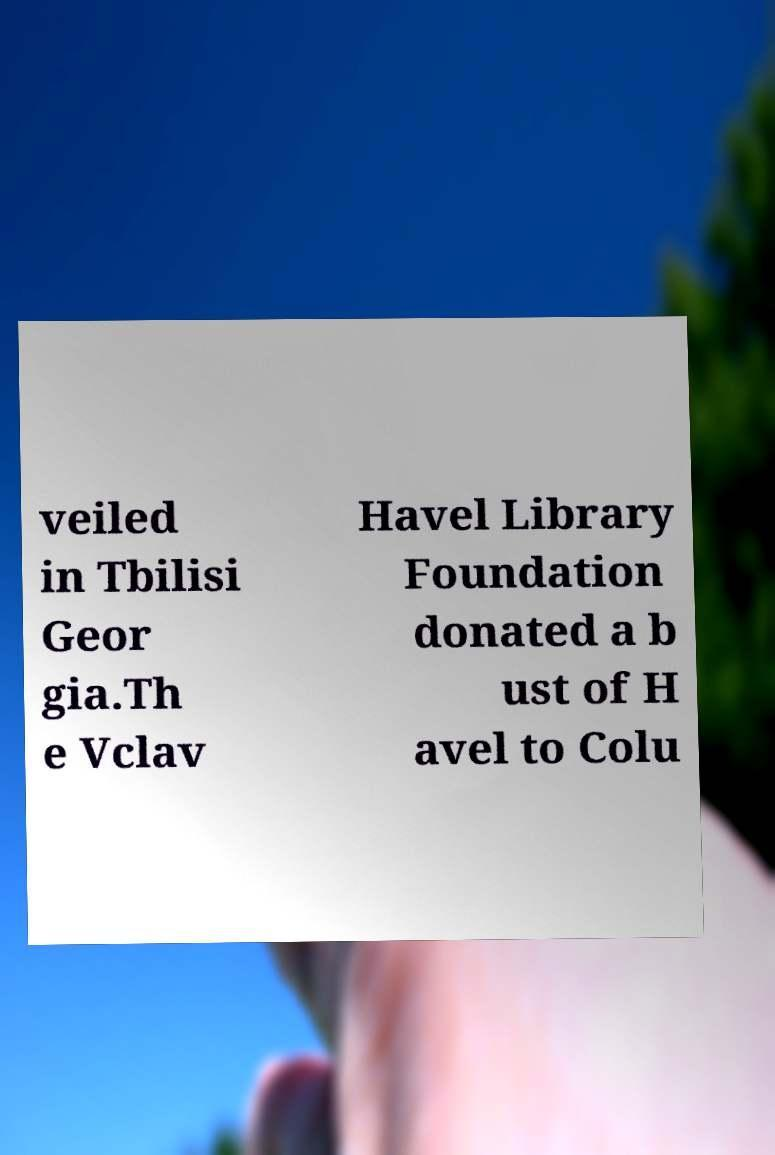Please read and relay the text visible in this image. What does it say? veiled in Tbilisi Geor gia.Th e Vclav Havel Library Foundation donated a b ust of H avel to Colu 